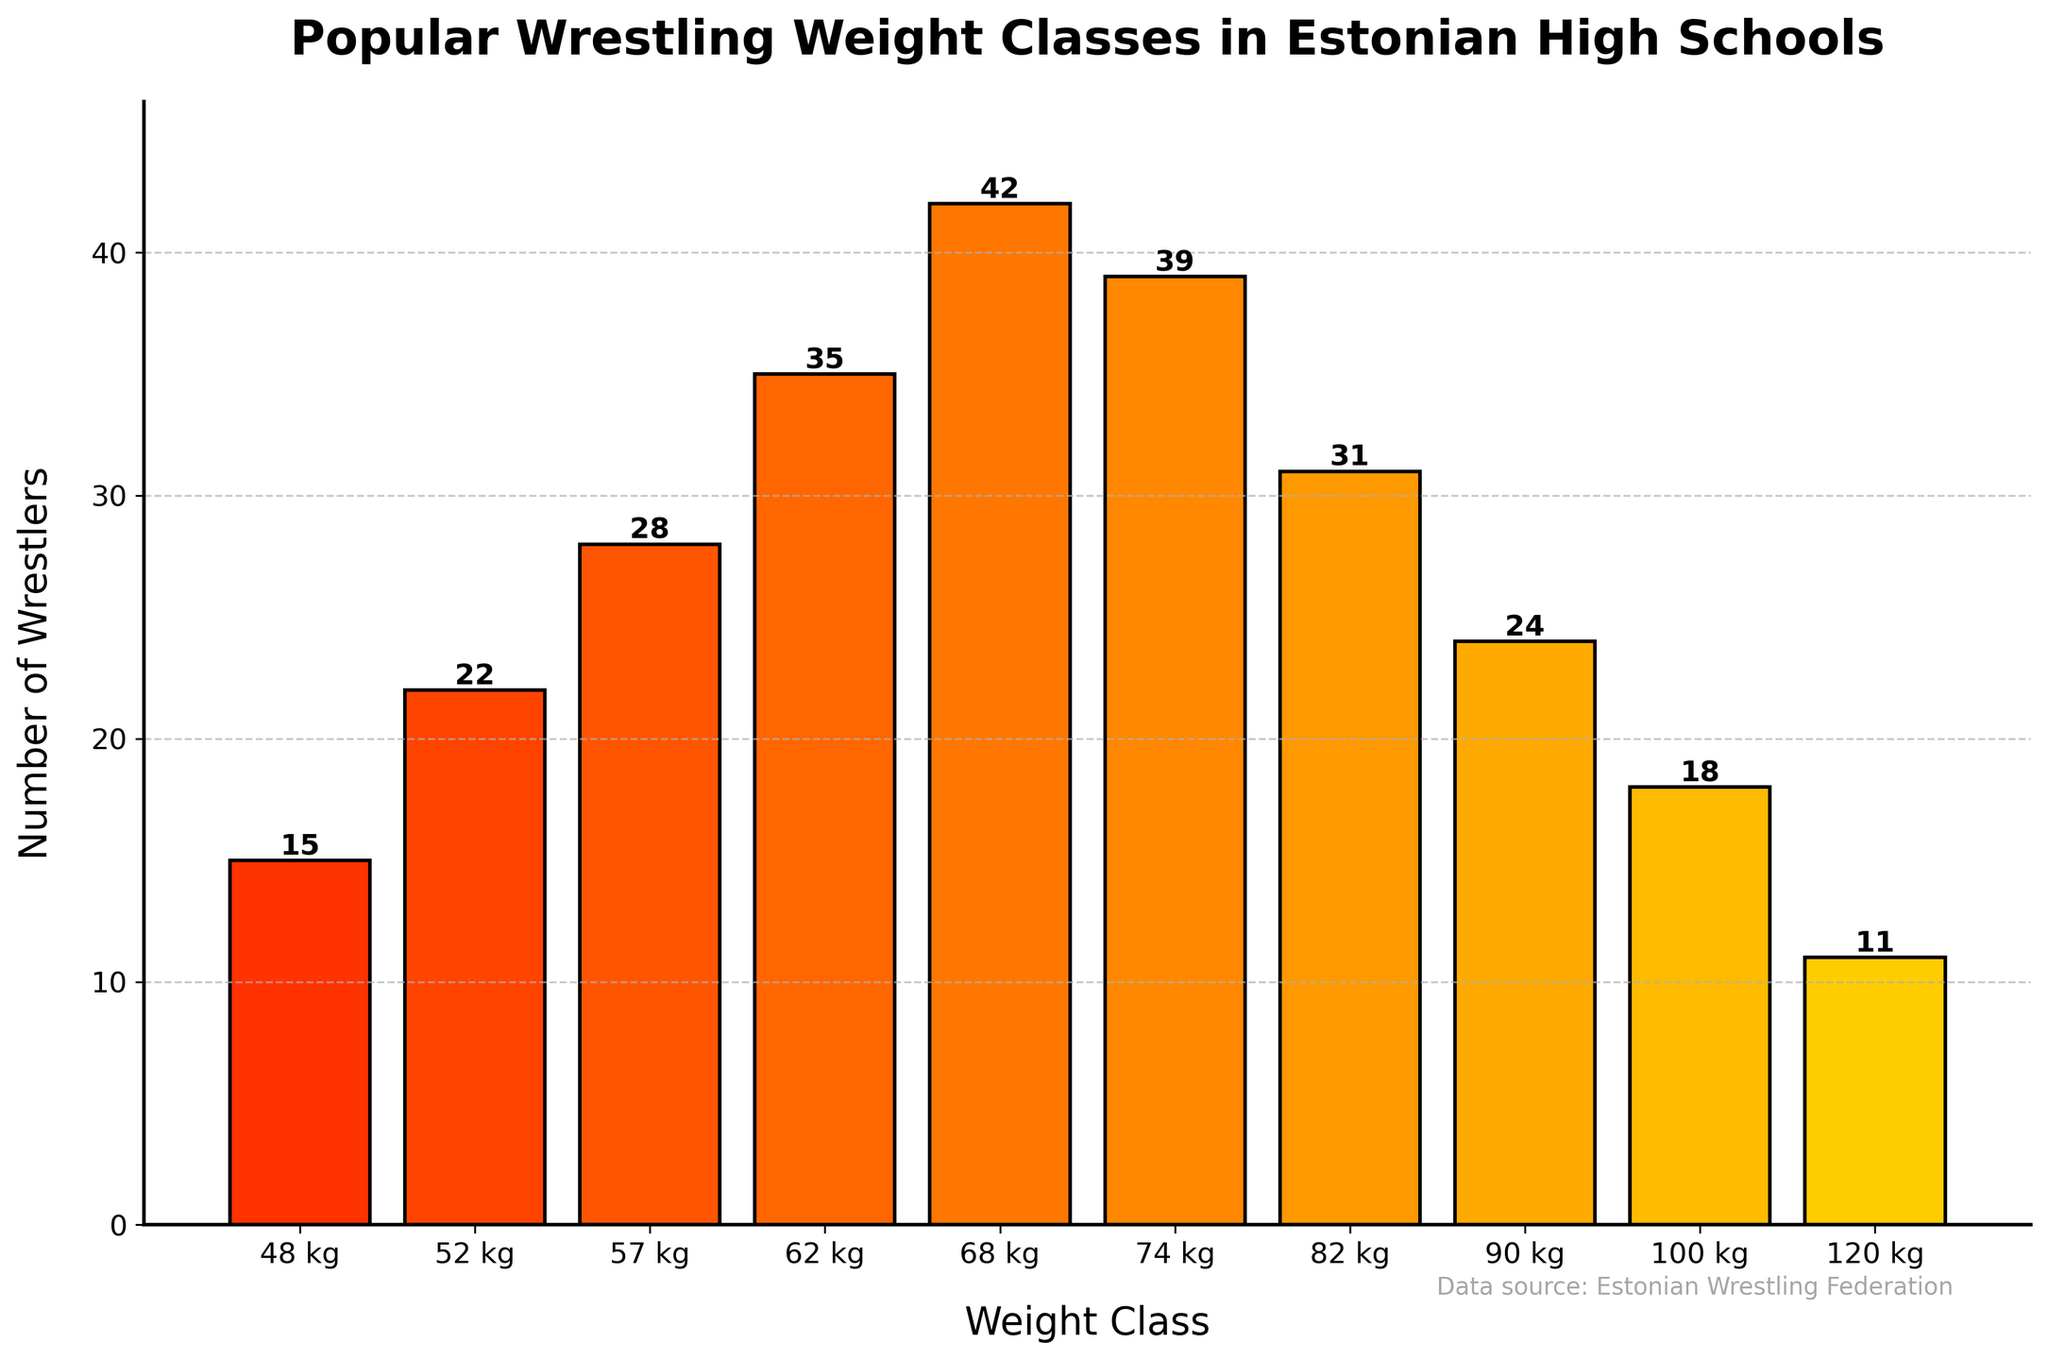Which weight class has the highest number of wrestlers? Examine the height of each bar. The bar with the greatest height represents the weight class with the highest number of wrestlers. The "68 kg" weight class has the highest bar.
Answer: 68 kg Which weight class has the fewest number of wrestlers? Look for the bar with the lowest height. The "120 kg" weight class has the shortest bar.
Answer: 120 kg What is the total number of wrestlers in weight classes below 60 kg? Sum the number of wrestlers in the "48 kg", "52 kg", and "57 kg" weight classes. 15 + 22 + 28 = 65.
Answer: 65 How many more wrestlers are in the 68 kg class compared to the 48 kg class? Subtract the number of wrestlers in the "48 kg" class from the number of wrestlers in the "68 kg" class. 42 - 15 = 27.
Answer: 27 Which two weight classes have the closest number of wrestlers? Compare the differences between adjacent bars. The "90 kg" and "100 kg" weight classes have the closest numbers, with 24 and 18 wrestlers respectively. Difference is 6.
Answer: 90 kg and 100 kg What is the average number of wrestlers in the weight classes that have more than 30 wrestlers each? Identify the relevant classes "57 kg", "62 kg", "68 kg", "74 kg", and "82 kg". Sum their wrestler counts and divide by the number of these classes: (28 + 35 + 42 + 39 + 31) / 5 = 35.
Answer: 35 Which weight class has the second highest number of wrestlers? Identify the tallest and then the second tallest bar. The tallest is "68 kg" and the second tallest is "74 kg".
Answer: 74 kg Are there more wrestlers in the 74 kg class or the combined number of wrestlers in the 120 kg and 100 kg classes? Sum the wrestlers in "100 kg" and "120 kg" classes and compare with "74 kg". 18 + 11 = 29 < 39.
Answer: 74 kg class What is the difference in height between the tallest bar and the shortest bar? Subtract the number of wrestlers in the "120 kg" class from the "68 kg" class. 42 - 11 = 31.
Answer: 31 In which range of weight classes do most wrestlers belong (below 60 kg, 60-90 kg, or above 90 kg)? Sum the number of wrestlers in each range: below 60 kg (15 + 22 + 28 = 65), 60-90 kg (35 + 42 + 39 + 31 + 24 = 171), above 90 kg (18 + 11 = 29). The range 60-90 kg has the most wrestlers.
Answer: 60-90 kg 